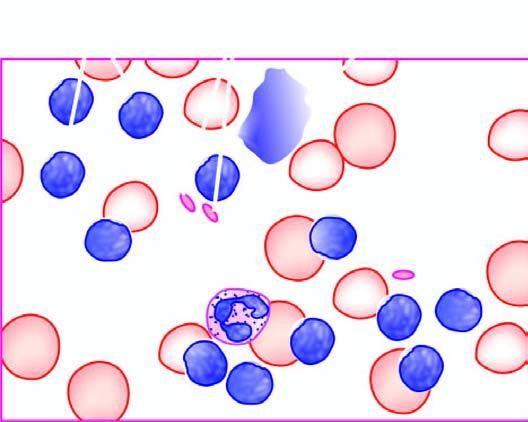s iron large excess of mature and small differentiated lymphocytes?
Answer the question using a single word or phrase. No 